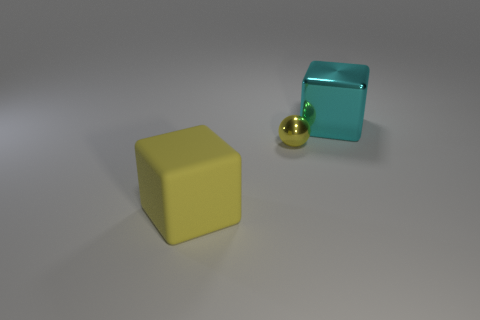There is another big object that is the same shape as the big yellow rubber object; what color is it?
Offer a terse response. Cyan. Do the rubber object and the small object behind the big yellow matte block have the same color?
Your answer should be very brief. Yes. What size is the thing that is both to the left of the cyan metal object and behind the large yellow matte object?
Your response must be concise. Small. Are there any small yellow shiny objects in front of the big cyan cube?
Your answer should be very brief. Yes. There is a block to the right of the yellow shiny sphere; are there any large cubes that are to the left of it?
Keep it short and to the point. Yes. Are there an equal number of small metal things on the right side of the metal ball and big blocks that are on the left side of the cyan metal thing?
Provide a short and direct response. No. What is the color of the cube that is the same material as the small yellow sphere?
Ensure brevity in your answer.  Cyan. Are there any other yellow blocks that have the same material as the yellow block?
Provide a short and direct response. No. What number of objects are cyan cubes or tiny balls?
Give a very brief answer. 2. Does the small ball have the same material as the large cube that is on the right side of the rubber block?
Your answer should be very brief. Yes. 